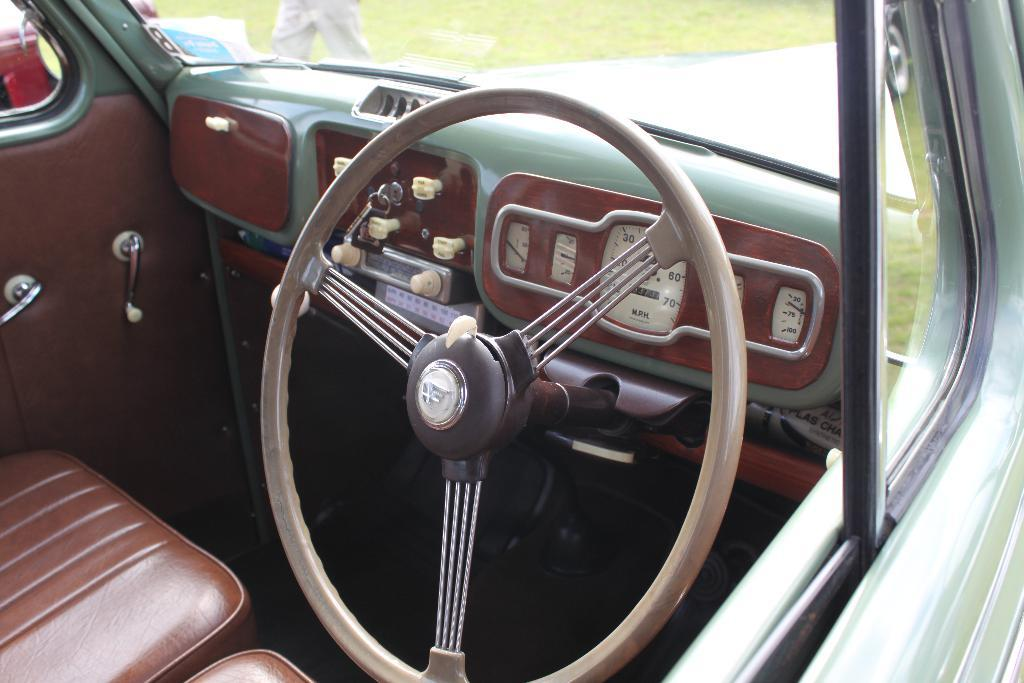What type of location is the image taken in? The image is taken inside a vehicle. What is the main feature in the center of the image? There is a steering wheel in the center of the image. What can be found beside the steering wheel? There are seats beside the steering wheel. What is visible at the top of the image? There is a glass on the top of the image. Can you see the carriage being pulled by horses in the image? There is no carriage or horses present in the image; it is taken inside a vehicle with a steering wheel and seats. How many fingers does the person driving the vehicle have in the image? There is no person visible in the image, so it is impossible to determine the number of fingers they might have. 